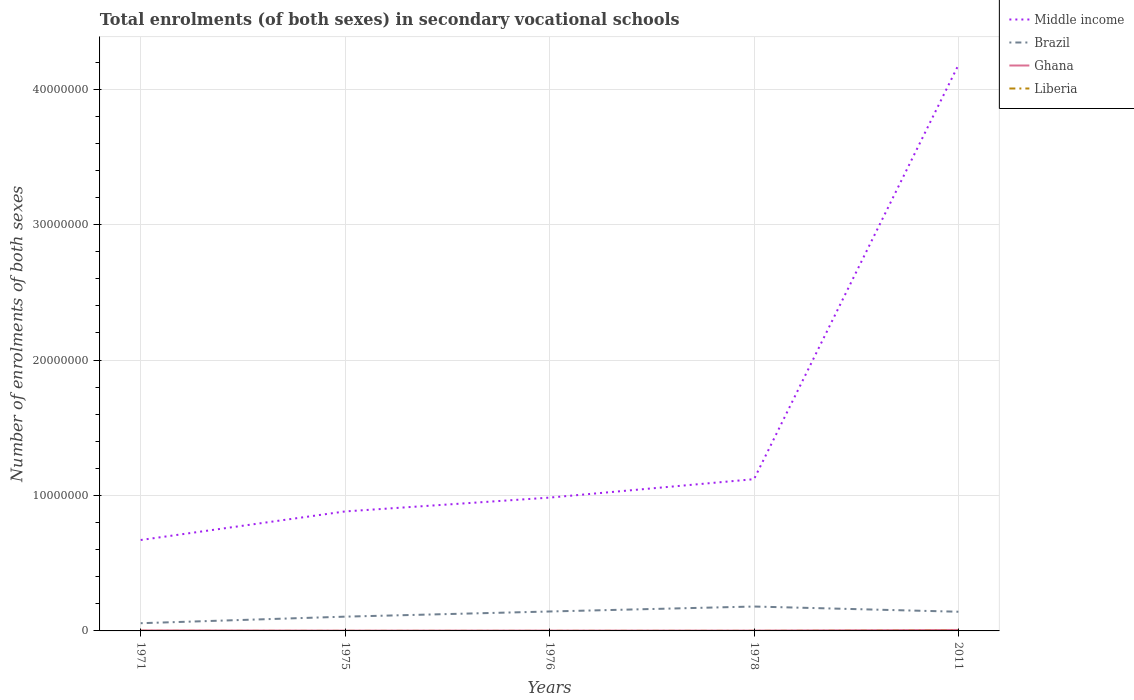Does the line corresponding to Ghana intersect with the line corresponding to Liberia?
Give a very brief answer. No. Is the number of lines equal to the number of legend labels?
Keep it short and to the point. Yes. Across all years, what is the maximum number of enrolments in secondary schools in Ghana?
Offer a terse response. 2.23e+04. In which year was the number of enrolments in secondary schools in Liberia maximum?
Give a very brief answer. 1971. What is the total number of enrolments in secondary schools in Liberia in the graph?
Your answer should be compact. -120. What is the difference between the highest and the second highest number of enrolments in secondary schools in Ghana?
Offer a terse response. 4.95e+04. What is the difference between two consecutive major ticks on the Y-axis?
Ensure brevity in your answer.  1.00e+07. Are the values on the major ticks of Y-axis written in scientific E-notation?
Offer a terse response. No. Does the graph contain grids?
Ensure brevity in your answer.  Yes. How are the legend labels stacked?
Offer a terse response. Vertical. What is the title of the graph?
Offer a terse response. Total enrolments (of both sexes) in secondary vocational schools. What is the label or title of the Y-axis?
Provide a succinct answer. Number of enrolments of both sexes. What is the Number of enrolments of both sexes in Middle income in 1971?
Your answer should be very brief. 6.71e+06. What is the Number of enrolments of both sexes of Brazil in 1971?
Offer a terse response. 5.70e+05. What is the Number of enrolments of both sexes in Ghana in 1971?
Make the answer very short. 3.96e+04. What is the Number of enrolments of both sexes of Liberia in 1971?
Make the answer very short. 1053. What is the Number of enrolments of both sexes of Middle income in 1975?
Give a very brief answer. 8.82e+06. What is the Number of enrolments of both sexes of Brazil in 1975?
Your answer should be compact. 1.05e+06. What is the Number of enrolments of both sexes of Ghana in 1975?
Your answer should be very brief. 2.23e+04. What is the Number of enrolments of both sexes in Liberia in 1975?
Your answer should be very brief. 1173. What is the Number of enrolments of both sexes of Middle income in 1976?
Ensure brevity in your answer.  9.84e+06. What is the Number of enrolments of both sexes of Brazil in 1976?
Provide a succinct answer. 1.43e+06. What is the Number of enrolments of both sexes in Ghana in 1976?
Keep it short and to the point. 2.35e+04. What is the Number of enrolments of both sexes of Liberia in 1976?
Ensure brevity in your answer.  1680. What is the Number of enrolments of both sexes of Middle income in 1978?
Provide a succinct answer. 1.12e+07. What is the Number of enrolments of both sexes of Brazil in 1978?
Provide a short and direct response. 1.80e+06. What is the Number of enrolments of both sexes of Ghana in 1978?
Your answer should be compact. 2.33e+04. What is the Number of enrolments of both sexes of Liberia in 1978?
Your answer should be compact. 1778. What is the Number of enrolments of both sexes in Middle income in 2011?
Provide a short and direct response. 4.18e+07. What is the Number of enrolments of both sexes of Brazil in 2011?
Your answer should be compact. 1.42e+06. What is the Number of enrolments of both sexes of Ghana in 2011?
Give a very brief answer. 7.18e+04. What is the Number of enrolments of both sexes in Liberia in 2011?
Your answer should be very brief. 1.76e+04. Across all years, what is the maximum Number of enrolments of both sexes in Middle income?
Provide a short and direct response. 4.18e+07. Across all years, what is the maximum Number of enrolments of both sexes in Brazil?
Offer a terse response. 1.80e+06. Across all years, what is the maximum Number of enrolments of both sexes of Ghana?
Provide a succinct answer. 7.18e+04. Across all years, what is the maximum Number of enrolments of both sexes of Liberia?
Keep it short and to the point. 1.76e+04. Across all years, what is the minimum Number of enrolments of both sexes of Middle income?
Provide a succinct answer. 6.71e+06. Across all years, what is the minimum Number of enrolments of both sexes of Brazil?
Your answer should be compact. 5.70e+05. Across all years, what is the minimum Number of enrolments of both sexes in Ghana?
Give a very brief answer. 2.23e+04. Across all years, what is the minimum Number of enrolments of both sexes of Liberia?
Offer a terse response. 1053. What is the total Number of enrolments of both sexes in Middle income in the graph?
Keep it short and to the point. 7.84e+07. What is the total Number of enrolments of both sexes of Brazil in the graph?
Provide a succinct answer. 6.28e+06. What is the total Number of enrolments of both sexes of Ghana in the graph?
Give a very brief answer. 1.81e+05. What is the total Number of enrolments of both sexes in Liberia in the graph?
Your answer should be very brief. 2.32e+04. What is the difference between the Number of enrolments of both sexes in Middle income in 1971 and that in 1975?
Offer a terse response. -2.11e+06. What is the difference between the Number of enrolments of both sexes in Brazil in 1971 and that in 1975?
Provide a short and direct response. -4.84e+05. What is the difference between the Number of enrolments of both sexes in Ghana in 1971 and that in 1975?
Give a very brief answer. 1.73e+04. What is the difference between the Number of enrolments of both sexes in Liberia in 1971 and that in 1975?
Offer a terse response. -120. What is the difference between the Number of enrolments of both sexes in Middle income in 1971 and that in 1976?
Offer a terse response. -3.13e+06. What is the difference between the Number of enrolments of both sexes in Brazil in 1971 and that in 1976?
Your answer should be very brief. -8.65e+05. What is the difference between the Number of enrolments of both sexes of Ghana in 1971 and that in 1976?
Your answer should be very brief. 1.62e+04. What is the difference between the Number of enrolments of both sexes of Liberia in 1971 and that in 1976?
Offer a terse response. -627. What is the difference between the Number of enrolments of both sexes of Middle income in 1971 and that in 1978?
Provide a short and direct response. -4.49e+06. What is the difference between the Number of enrolments of both sexes in Brazil in 1971 and that in 1978?
Offer a very short reply. -1.23e+06. What is the difference between the Number of enrolments of both sexes of Ghana in 1971 and that in 1978?
Make the answer very short. 1.63e+04. What is the difference between the Number of enrolments of both sexes of Liberia in 1971 and that in 1978?
Your response must be concise. -725. What is the difference between the Number of enrolments of both sexes of Middle income in 1971 and that in 2011?
Your answer should be very brief. -3.51e+07. What is the difference between the Number of enrolments of both sexes of Brazil in 1971 and that in 2011?
Offer a terse response. -8.46e+05. What is the difference between the Number of enrolments of both sexes in Ghana in 1971 and that in 2011?
Your answer should be very brief. -3.22e+04. What is the difference between the Number of enrolments of both sexes in Liberia in 1971 and that in 2011?
Your answer should be compact. -1.65e+04. What is the difference between the Number of enrolments of both sexes in Middle income in 1975 and that in 1976?
Offer a terse response. -1.02e+06. What is the difference between the Number of enrolments of both sexes of Brazil in 1975 and that in 1976?
Provide a short and direct response. -3.81e+05. What is the difference between the Number of enrolments of both sexes in Ghana in 1975 and that in 1976?
Your response must be concise. -1121. What is the difference between the Number of enrolments of both sexes of Liberia in 1975 and that in 1976?
Your response must be concise. -507. What is the difference between the Number of enrolments of both sexes in Middle income in 1975 and that in 1978?
Make the answer very short. -2.38e+06. What is the difference between the Number of enrolments of both sexes of Brazil in 1975 and that in 1978?
Give a very brief answer. -7.48e+05. What is the difference between the Number of enrolments of both sexes of Ghana in 1975 and that in 1978?
Offer a terse response. -976. What is the difference between the Number of enrolments of both sexes of Liberia in 1975 and that in 1978?
Your response must be concise. -605. What is the difference between the Number of enrolments of both sexes of Middle income in 1975 and that in 2011?
Your response must be concise. -3.30e+07. What is the difference between the Number of enrolments of both sexes in Brazil in 1975 and that in 2011?
Keep it short and to the point. -3.63e+05. What is the difference between the Number of enrolments of both sexes in Ghana in 1975 and that in 2011?
Ensure brevity in your answer.  -4.95e+04. What is the difference between the Number of enrolments of both sexes in Liberia in 1975 and that in 2011?
Keep it short and to the point. -1.64e+04. What is the difference between the Number of enrolments of both sexes of Middle income in 1976 and that in 1978?
Your answer should be compact. -1.36e+06. What is the difference between the Number of enrolments of both sexes in Brazil in 1976 and that in 1978?
Your answer should be very brief. -3.67e+05. What is the difference between the Number of enrolments of both sexes in Ghana in 1976 and that in 1978?
Offer a terse response. 145. What is the difference between the Number of enrolments of both sexes in Liberia in 1976 and that in 1978?
Make the answer very short. -98. What is the difference between the Number of enrolments of both sexes in Middle income in 1976 and that in 2011?
Make the answer very short. -3.20e+07. What is the difference between the Number of enrolments of both sexes in Brazil in 1976 and that in 2011?
Your answer should be very brief. 1.85e+04. What is the difference between the Number of enrolments of both sexes of Ghana in 1976 and that in 2011?
Your answer should be compact. -4.84e+04. What is the difference between the Number of enrolments of both sexes of Liberia in 1976 and that in 2011?
Provide a short and direct response. -1.59e+04. What is the difference between the Number of enrolments of both sexes in Middle income in 1978 and that in 2011?
Give a very brief answer. -3.06e+07. What is the difference between the Number of enrolments of both sexes in Brazil in 1978 and that in 2011?
Offer a very short reply. 3.85e+05. What is the difference between the Number of enrolments of both sexes of Ghana in 1978 and that in 2011?
Provide a short and direct response. -4.85e+04. What is the difference between the Number of enrolments of both sexes in Liberia in 1978 and that in 2011?
Make the answer very short. -1.58e+04. What is the difference between the Number of enrolments of both sexes in Middle income in 1971 and the Number of enrolments of both sexes in Brazil in 1975?
Provide a short and direct response. 5.66e+06. What is the difference between the Number of enrolments of both sexes of Middle income in 1971 and the Number of enrolments of both sexes of Ghana in 1975?
Keep it short and to the point. 6.69e+06. What is the difference between the Number of enrolments of both sexes of Middle income in 1971 and the Number of enrolments of both sexes of Liberia in 1975?
Your answer should be compact. 6.71e+06. What is the difference between the Number of enrolments of both sexes of Brazil in 1971 and the Number of enrolments of both sexes of Ghana in 1975?
Offer a very short reply. 5.48e+05. What is the difference between the Number of enrolments of both sexes of Brazil in 1971 and the Number of enrolments of both sexes of Liberia in 1975?
Provide a short and direct response. 5.69e+05. What is the difference between the Number of enrolments of both sexes of Ghana in 1971 and the Number of enrolments of both sexes of Liberia in 1975?
Your answer should be very brief. 3.85e+04. What is the difference between the Number of enrolments of both sexes in Middle income in 1971 and the Number of enrolments of both sexes in Brazil in 1976?
Provide a succinct answer. 5.28e+06. What is the difference between the Number of enrolments of both sexes in Middle income in 1971 and the Number of enrolments of both sexes in Ghana in 1976?
Provide a succinct answer. 6.69e+06. What is the difference between the Number of enrolments of both sexes of Middle income in 1971 and the Number of enrolments of both sexes of Liberia in 1976?
Provide a succinct answer. 6.71e+06. What is the difference between the Number of enrolments of both sexes of Brazil in 1971 and the Number of enrolments of both sexes of Ghana in 1976?
Provide a succinct answer. 5.47e+05. What is the difference between the Number of enrolments of both sexes in Brazil in 1971 and the Number of enrolments of both sexes in Liberia in 1976?
Make the answer very short. 5.68e+05. What is the difference between the Number of enrolments of both sexes of Ghana in 1971 and the Number of enrolments of both sexes of Liberia in 1976?
Keep it short and to the point. 3.80e+04. What is the difference between the Number of enrolments of both sexes in Middle income in 1971 and the Number of enrolments of both sexes in Brazil in 1978?
Give a very brief answer. 4.91e+06. What is the difference between the Number of enrolments of both sexes in Middle income in 1971 and the Number of enrolments of both sexes in Ghana in 1978?
Ensure brevity in your answer.  6.69e+06. What is the difference between the Number of enrolments of both sexes in Middle income in 1971 and the Number of enrolments of both sexes in Liberia in 1978?
Provide a short and direct response. 6.71e+06. What is the difference between the Number of enrolments of both sexes in Brazil in 1971 and the Number of enrolments of both sexes in Ghana in 1978?
Give a very brief answer. 5.47e+05. What is the difference between the Number of enrolments of both sexes of Brazil in 1971 and the Number of enrolments of both sexes of Liberia in 1978?
Ensure brevity in your answer.  5.68e+05. What is the difference between the Number of enrolments of both sexes of Ghana in 1971 and the Number of enrolments of both sexes of Liberia in 1978?
Give a very brief answer. 3.79e+04. What is the difference between the Number of enrolments of both sexes of Middle income in 1971 and the Number of enrolments of both sexes of Brazil in 2011?
Ensure brevity in your answer.  5.30e+06. What is the difference between the Number of enrolments of both sexes in Middle income in 1971 and the Number of enrolments of both sexes in Ghana in 2011?
Give a very brief answer. 6.64e+06. What is the difference between the Number of enrolments of both sexes of Middle income in 1971 and the Number of enrolments of both sexes of Liberia in 2011?
Offer a very short reply. 6.70e+06. What is the difference between the Number of enrolments of both sexes in Brazil in 1971 and the Number of enrolments of both sexes in Ghana in 2011?
Provide a succinct answer. 4.98e+05. What is the difference between the Number of enrolments of both sexes in Brazil in 1971 and the Number of enrolments of both sexes in Liberia in 2011?
Make the answer very short. 5.53e+05. What is the difference between the Number of enrolments of both sexes in Ghana in 1971 and the Number of enrolments of both sexes in Liberia in 2011?
Give a very brief answer. 2.21e+04. What is the difference between the Number of enrolments of both sexes of Middle income in 1975 and the Number of enrolments of both sexes of Brazil in 1976?
Your answer should be very brief. 7.39e+06. What is the difference between the Number of enrolments of both sexes of Middle income in 1975 and the Number of enrolments of both sexes of Ghana in 1976?
Your answer should be very brief. 8.80e+06. What is the difference between the Number of enrolments of both sexes of Middle income in 1975 and the Number of enrolments of both sexes of Liberia in 1976?
Provide a short and direct response. 8.82e+06. What is the difference between the Number of enrolments of both sexes of Brazil in 1975 and the Number of enrolments of both sexes of Ghana in 1976?
Ensure brevity in your answer.  1.03e+06. What is the difference between the Number of enrolments of both sexes in Brazil in 1975 and the Number of enrolments of both sexes in Liberia in 1976?
Give a very brief answer. 1.05e+06. What is the difference between the Number of enrolments of both sexes of Ghana in 1975 and the Number of enrolments of both sexes of Liberia in 1976?
Provide a short and direct response. 2.07e+04. What is the difference between the Number of enrolments of both sexes in Middle income in 1975 and the Number of enrolments of both sexes in Brazil in 1978?
Your answer should be compact. 7.02e+06. What is the difference between the Number of enrolments of both sexes of Middle income in 1975 and the Number of enrolments of both sexes of Ghana in 1978?
Give a very brief answer. 8.80e+06. What is the difference between the Number of enrolments of both sexes of Middle income in 1975 and the Number of enrolments of both sexes of Liberia in 1978?
Give a very brief answer. 8.82e+06. What is the difference between the Number of enrolments of both sexes of Brazil in 1975 and the Number of enrolments of both sexes of Ghana in 1978?
Give a very brief answer. 1.03e+06. What is the difference between the Number of enrolments of both sexes of Brazil in 1975 and the Number of enrolments of both sexes of Liberia in 1978?
Provide a succinct answer. 1.05e+06. What is the difference between the Number of enrolments of both sexes of Ghana in 1975 and the Number of enrolments of both sexes of Liberia in 1978?
Provide a short and direct response. 2.06e+04. What is the difference between the Number of enrolments of both sexes in Middle income in 1975 and the Number of enrolments of both sexes in Brazil in 2011?
Ensure brevity in your answer.  7.41e+06. What is the difference between the Number of enrolments of both sexes in Middle income in 1975 and the Number of enrolments of both sexes in Ghana in 2011?
Make the answer very short. 8.75e+06. What is the difference between the Number of enrolments of both sexes of Middle income in 1975 and the Number of enrolments of both sexes of Liberia in 2011?
Provide a short and direct response. 8.81e+06. What is the difference between the Number of enrolments of both sexes in Brazil in 1975 and the Number of enrolments of both sexes in Ghana in 2011?
Provide a short and direct response. 9.82e+05. What is the difference between the Number of enrolments of both sexes of Brazil in 1975 and the Number of enrolments of both sexes of Liberia in 2011?
Your answer should be very brief. 1.04e+06. What is the difference between the Number of enrolments of both sexes in Ghana in 1975 and the Number of enrolments of both sexes in Liberia in 2011?
Provide a short and direct response. 4774. What is the difference between the Number of enrolments of both sexes in Middle income in 1976 and the Number of enrolments of both sexes in Brazil in 1978?
Give a very brief answer. 8.04e+06. What is the difference between the Number of enrolments of both sexes of Middle income in 1976 and the Number of enrolments of both sexes of Ghana in 1978?
Offer a very short reply. 9.82e+06. What is the difference between the Number of enrolments of both sexes in Middle income in 1976 and the Number of enrolments of both sexes in Liberia in 1978?
Keep it short and to the point. 9.84e+06. What is the difference between the Number of enrolments of both sexes in Brazil in 1976 and the Number of enrolments of both sexes in Ghana in 1978?
Provide a succinct answer. 1.41e+06. What is the difference between the Number of enrolments of both sexes of Brazil in 1976 and the Number of enrolments of both sexes of Liberia in 1978?
Your response must be concise. 1.43e+06. What is the difference between the Number of enrolments of both sexes of Ghana in 1976 and the Number of enrolments of both sexes of Liberia in 1978?
Provide a short and direct response. 2.17e+04. What is the difference between the Number of enrolments of both sexes of Middle income in 1976 and the Number of enrolments of both sexes of Brazil in 2011?
Give a very brief answer. 8.43e+06. What is the difference between the Number of enrolments of both sexes of Middle income in 1976 and the Number of enrolments of both sexes of Ghana in 2011?
Ensure brevity in your answer.  9.77e+06. What is the difference between the Number of enrolments of both sexes of Middle income in 1976 and the Number of enrolments of both sexes of Liberia in 2011?
Give a very brief answer. 9.83e+06. What is the difference between the Number of enrolments of both sexes of Brazil in 1976 and the Number of enrolments of both sexes of Ghana in 2011?
Ensure brevity in your answer.  1.36e+06. What is the difference between the Number of enrolments of both sexes of Brazil in 1976 and the Number of enrolments of both sexes of Liberia in 2011?
Ensure brevity in your answer.  1.42e+06. What is the difference between the Number of enrolments of both sexes in Ghana in 1976 and the Number of enrolments of both sexes in Liberia in 2011?
Provide a succinct answer. 5895. What is the difference between the Number of enrolments of both sexes of Middle income in 1978 and the Number of enrolments of both sexes of Brazil in 2011?
Offer a terse response. 9.79e+06. What is the difference between the Number of enrolments of both sexes in Middle income in 1978 and the Number of enrolments of both sexes in Ghana in 2011?
Your answer should be compact. 1.11e+07. What is the difference between the Number of enrolments of both sexes of Middle income in 1978 and the Number of enrolments of both sexes of Liberia in 2011?
Provide a short and direct response. 1.12e+07. What is the difference between the Number of enrolments of both sexes of Brazil in 1978 and the Number of enrolments of both sexes of Ghana in 2011?
Provide a succinct answer. 1.73e+06. What is the difference between the Number of enrolments of both sexes of Brazil in 1978 and the Number of enrolments of both sexes of Liberia in 2011?
Keep it short and to the point. 1.78e+06. What is the difference between the Number of enrolments of both sexes of Ghana in 1978 and the Number of enrolments of both sexes of Liberia in 2011?
Your response must be concise. 5750. What is the average Number of enrolments of both sexes in Middle income per year?
Make the answer very short. 1.57e+07. What is the average Number of enrolments of both sexes of Brazil per year?
Your answer should be very brief. 1.26e+06. What is the average Number of enrolments of both sexes of Ghana per year?
Provide a succinct answer. 3.61e+04. What is the average Number of enrolments of both sexes of Liberia per year?
Make the answer very short. 4649.8. In the year 1971, what is the difference between the Number of enrolments of both sexes in Middle income and Number of enrolments of both sexes in Brazil?
Provide a short and direct response. 6.14e+06. In the year 1971, what is the difference between the Number of enrolments of both sexes of Middle income and Number of enrolments of both sexes of Ghana?
Your answer should be compact. 6.67e+06. In the year 1971, what is the difference between the Number of enrolments of both sexes in Middle income and Number of enrolments of both sexes in Liberia?
Keep it short and to the point. 6.71e+06. In the year 1971, what is the difference between the Number of enrolments of both sexes of Brazil and Number of enrolments of both sexes of Ghana?
Provide a succinct answer. 5.30e+05. In the year 1971, what is the difference between the Number of enrolments of both sexes in Brazil and Number of enrolments of both sexes in Liberia?
Provide a succinct answer. 5.69e+05. In the year 1971, what is the difference between the Number of enrolments of both sexes in Ghana and Number of enrolments of both sexes in Liberia?
Ensure brevity in your answer.  3.86e+04. In the year 1975, what is the difference between the Number of enrolments of both sexes of Middle income and Number of enrolments of both sexes of Brazil?
Your answer should be very brief. 7.77e+06. In the year 1975, what is the difference between the Number of enrolments of both sexes of Middle income and Number of enrolments of both sexes of Ghana?
Offer a terse response. 8.80e+06. In the year 1975, what is the difference between the Number of enrolments of both sexes of Middle income and Number of enrolments of both sexes of Liberia?
Provide a short and direct response. 8.82e+06. In the year 1975, what is the difference between the Number of enrolments of both sexes of Brazil and Number of enrolments of both sexes of Ghana?
Offer a very short reply. 1.03e+06. In the year 1975, what is the difference between the Number of enrolments of both sexes of Brazil and Number of enrolments of both sexes of Liberia?
Keep it short and to the point. 1.05e+06. In the year 1975, what is the difference between the Number of enrolments of both sexes of Ghana and Number of enrolments of both sexes of Liberia?
Ensure brevity in your answer.  2.12e+04. In the year 1976, what is the difference between the Number of enrolments of both sexes in Middle income and Number of enrolments of both sexes in Brazil?
Provide a short and direct response. 8.41e+06. In the year 1976, what is the difference between the Number of enrolments of both sexes of Middle income and Number of enrolments of both sexes of Ghana?
Give a very brief answer. 9.82e+06. In the year 1976, what is the difference between the Number of enrolments of both sexes of Middle income and Number of enrolments of both sexes of Liberia?
Give a very brief answer. 9.84e+06. In the year 1976, what is the difference between the Number of enrolments of both sexes of Brazil and Number of enrolments of both sexes of Ghana?
Your response must be concise. 1.41e+06. In the year 1976, what is the difference between the Number of enrolments of both sexes in Brazil and Number of enrolments of both sexes in Liberia?
Ensure brevity in your answer.  1.43e+06. In the year 1976, what is the difference between the Number of enrolments of both sexes in Ghana and Number of enrolments of both sexes in Liberia?
Give a very brief answer. 2.18e+04. In the year 1978, what is the difference between the Number of enrolments of both sexes of Middle income and Number of enrolments of both sexes of Brazil?
Make the answer very short. 9.40e+06. In the year 1978, what is the difference between the Number of enrolments of both sexes of Middle income and Number of enrolments of both sexes of Ghana?
Provide a short and direct response. 1.12e+07. In the year 1978, what is the difference between the Number of enrolments of both sexes of Middle income and Number of enrolments of both sexes of Liberia?
Your answer should be compact. 1.12e+07. In the year 1978, what is the difference between the Number of enrolments of both sexes of Brazil and Number of enrolments of both sexes of Ghana?
Your answer should be very brief. 1.78e+06. In the year 1978, what is the difference between the Number of enrolments of both sexes of Brazil and Number of enrolments of both sexes of Liberia?
Keep it short and to the point. 1.80e+06. In the year 1978, what is the difference between the Number of enrolments of both sexes of Ghana and Number of enrolments of both sexes of Liberia?
Provide a succinct answer. 2.15e+04. In the year 2011, what is the difference between the Number of enrolments of both sexes of Middle income and Number of enrolments of both sexes of Brazil?
Give a very brief answer. 4.04e+07. In the year 2011, what is the difference between the Number of enrolments of both sexes of Middle income and Number of enrolments of both sexes of Ghana?
Ensure brevity in your answer.  4.17e+07. In the year 2011, what is the difference between the Number of enrolments of both sexes of Middle income and Number of enrolments of both sexes of Liberia?
Give a very brief answer. 4.18e+07. In the year 2011, what is the difference between the Number of enrolments of both sexes of Brazil and Number of enrolments of both sexes of Ghana?
Keep it short and to the point. 1.34e+06. In the year 2011, what is the difference between the Number of enrolments of both sexes in Brazil and Number of enrolments of both sexes in Liberia?
Your response must be concise. 1.40e+06. In the year 2011, what is the difference between the Number of enrolments of both sexes of Ghana and Number of enrolments of both sexes of Liberia?
Offer a very short reply. 5.43e+04. What is the ratio of the Number of enrolments of both sexes of Middle income in 1971 to that in 1975?
Your response must be concise. 0.76. What is the ratio of the Number of enrolments of both sexes in Brazil in 1971 to that in 1975?
Your answer should be compact. 0.54. What is the ratio of the Number of enrolments of both sexes in Ghana in 1971 to that in 1975?
Your answer should be compact. 1.77. What is the ratio of the Number of enrolments of both sexes in Liberia in 1971 to that in 1975?
Your response must be concise. 0.9. What is the ratio of the Number of enrolments of both sexes of Middle income in 1971 to that in 1976?
Provide a succinct answer. 0.68. What is the ratio of the Number of enrolments of both sexes in Brazil in 1971 to that in 1976?
Ensure brevity in your answer.  0.4. What is the ratio of the Number of enrolments of both sexes in Ghana in 1971 to that in 1976?
Offer a very short reply. 1.69. What is the ratio of the Number of enrolments of both sexes of Liberia in 1971 to that in 1976?
Give a very brief answer. 0.63. What is the ratio of the Number of enrolments of both sexes in Middle income in 1971 to that in 1978?
Offer a very short reply. 0.6. What is the ratio of the Number of enrolments of both sexes in Brazil in 1971 to that in 1978?
Make the answer very short. 0.32. What is the ratio of the Number of enrolments of both sexes in Ghana in 1971 to that in 1978?
Ensure brevity in your answer.  1.7. What is the ratio of the Number of enrolments of both sexes of Liberia in 1971 to that in 1978?
Give a very brief answer. 0.59. What is the ratio of the Number of enrolments of both sexes in Middle income in 1971 to that in 2011?
Your answer should be very brief. 0.16. What is the ratio of the Number of enrolments of both sexes of Brazil in 1971 to that in 2011?
Make the answer very short. 0.4. What is the ratio of the Number of enrolments of both sexes in Ghana in 1971 to that in 2011?
Ensure brevity in your answer.  0.55. What is the ratio of the Number of enrolments of both sexes in Liberia in 1971 to that in 2011?
Ensure brevity in your answer.  0.06. What is the ratio of the Number of enrolments of both sexes of Middle income in 1975 to that in 1976?
Give a very brief answer. 0.9. What is the ratio of the Number of enrolments of both sexes of Brazil in 1975 to that in 1976?
Provide a short and direct response. 0.73. What is the ratio of the Number of enrolments of both sexes in Ghana in 1975 to that in 1976?
Make the answer very short. 0.95. What is the ratio of the Number of enrolments of both sexes in Liberia in 1975 to that in 1976?
Provide a short and direct response. 0.7. What is the ratio of the Number of enrolments of both sexes of Middle income in 1975 to that in 1978?
Make the answer very short. 0.79. What is the ratio of the Number of enrolments of both sexes in Brazil in 1975 to that in 1978?
Give a very brief answer. 0.58. What is the ratio of the Number of enrolments of both sexes of Ghana in 1975 to that in 1978?
Offer a very short reply. 0.96. What is the ratio of the Number of enrolments of both sexes in Liberia in 1975 to that in 1978?
Provide a short and direct response. 0.66. What is the ratio of the Number of enrolments of both sexes of Middle income in 1975 to that in 2011?
Give a very brief answer. 0.21. What is the ratio of the Number of enrolments of both sexes of Brazil in 1975 to that in 2011?
Offer a very short reply. 0.74. What is the ratio of the Number of enrolments of both sexes in Ghana in 1975 to that in 2011?
Offer a terse response. 0.31. What is the ratio of the Number of enrolments of both sexes in Liberia in 1975 to that in 2011?
Offer a very short reply. 0.07. What is the ratio of the Number of enrolments of both sexes of Middle income in 1976 to that in 1978?
Offer a very short reply. 0.88. What is the ratio of the Number of enrolments of both sexes in Brazil in 1976 to that in 1978?
Ensure brevity in your answer.  0.8. What is the ratio of the Number of enrolments of both sexes of Liberia in 1976 to that in 1978?
Your answer should be very brief. 0.94. What is the ratio of the Number of enrolments of both sexes in Middle income in 1976 to that in 2011?
Offer a terse response. 0.24. What is the ratio of the Number of enrolments of both sexes of Ghana in 1976 to that in 2011?
Offer a very short reply. 0.33. What is the ratio of the Number of enrolments of both sexes in Liberia in 1976 to that in 2011?
Make the answer very short. 0.1. What is the ratio of the Number of enrolments of both sexes of Middle income in 1978 to that in 2011?
Offer a very short reply. 0.27. What is the ratio of the Number of enrolments of both sexes in Brazil in 1978 to that in 2011?
Keep it short and to the point. 1.27. What is the ratio of the Number of enrolments of both sexes of Ghana in 1978 to that in 2011?
Your answer should be very brief. 0.32. What is the ratio of the Number of enrolments of both sexes in Liberia in 1978 to that in 2011?
Your answer should be compact. 0.1. What is the difference between the highest and the second highest Number of enrolments of both sexes of Middle income?
Your answer should be compact. 3.06e+07. What is the difference between the highest and the second highest Number of enrolments of both sexes of Brazil?
Make the answer very short. 3.67e+05. What is the difference between the highest and the second highest Number of enrolments of both sexes in Ghana?
Provide a succinct answer. 3.22e+04. What is the difference between the highest and the second highest Number of enrolments of both sexes of Liberia?
Provide a short and direct response. 1.58e+04. What is the difference between the highest and the lowest Number of enrolments of both sexes in Middle income?
Provide a short and direct response. 3.51e+07. What is the difference between the highest and the lowest Number of enrolments of both sexes in Brazil?
Make the answer very short. 1.23e+06. What is the difference between the highest and the lowest Number of enrolments of both sexes of Ghana?
Give a very brief answer. 4.95e+04. What is the difference between the highest and the lowest Number of enrolments of both sexes in Liberia?
Your response must be concise. 1.65e+04. 